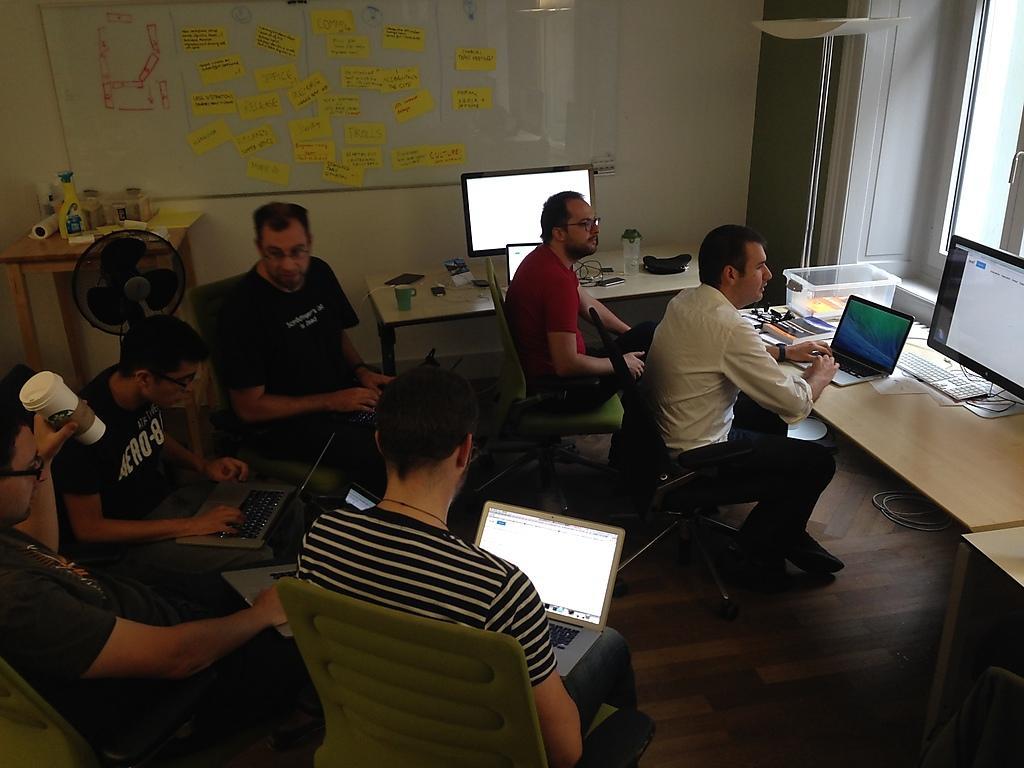In one or two sentences, can you explain what this image depicts? In this image on the right, there is a man, he wears a shirt, trouser, he is sitting on the chair. In the middle there is a man, he wears a t shirt, trouser, he is sitting on the chair, he is using a laptop. On the left there are three men, they are siting. At the top there is a man, he wears a red t shirt, trouser, he is sitting on the chair, behind him there is a table on that there are cups, bags, monitor. In the background there are bottles, rolls, poster, text, window and wall. 